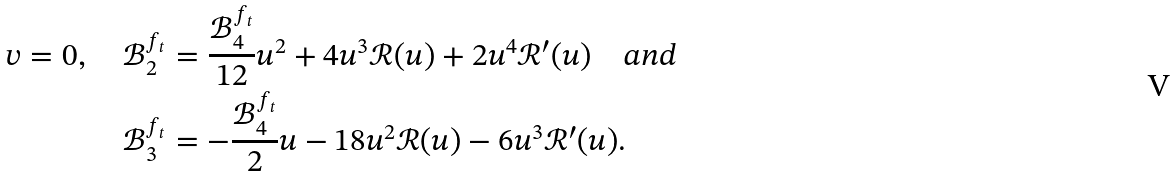Convert formula to latex. <formula><loc_0><loc_0><loc_500><loc_500>v = 0 , \quad \mathcal { B } ^ { f _ { t } } _ { 2 } & = \frac { \mathcal { B } _ { 4 } ^ { f _ { t } } } { 1 2 } u ^ { 2 } + 4 u ^ { 3 } \mathcal { R } ( u ) + 2 u ^ { 4 } \mathcal { R } ^ { \prime } ( u ) \quad a n d \\ \mathcal { B } ^ { f _ { t } } _ { 3 } & = - \frac { \mathcal { B } _ { 4 } ^ { f _ { t } } } { 2 } u - 1 8 u ^ { 2 } \mathcal { R } ( u ) - 6 u ^ { 3 } \mathcal { R } ^ { \prime } ( u ) .</formula> 